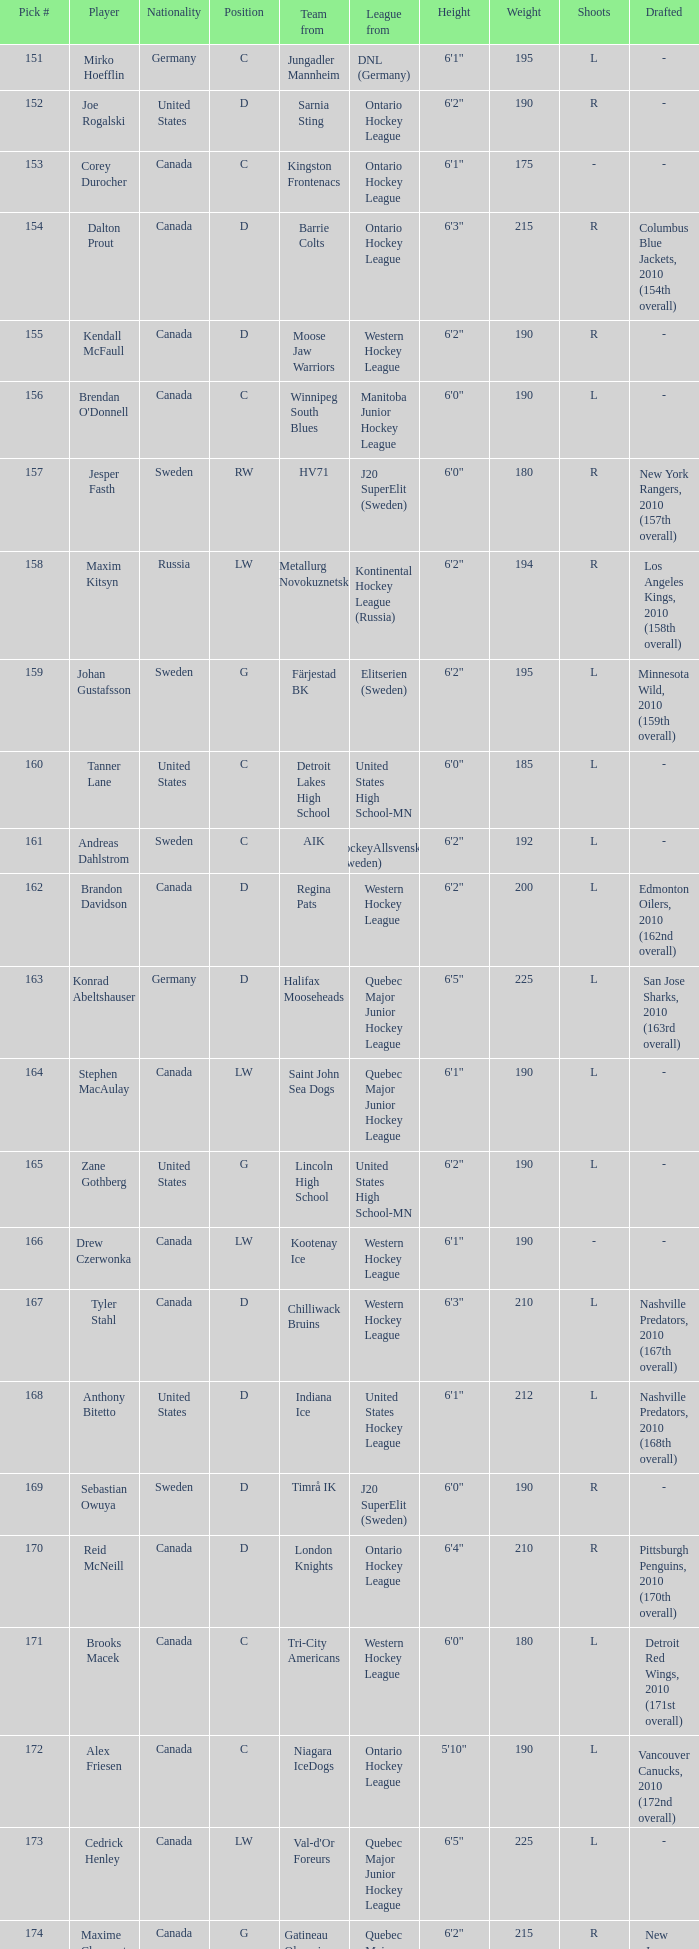Parse the full table. {'header': ['Pick #', 'Player', 'Nationality', 'Position', 'Team from', 'League from', 'Height', 'Weight', 'Shoots', 'Drafted'], 'rows': [['151', 'Mirko Hoefflin', 'Germany', 'C', 'Jungadler Mannheim', 'DNL (Germany)', '6\'1"', '195', 'L', '-'], ['152', 'Joe Rogalski', 'United States', 'D', 'Sarnia Sting', 'Ontario Hockey League', '6\'2"', '190', 'R', '-'], ['153', 'Corey Durocher', 'Canada', 'C', 'Kingston Frontenacs', 'Ontario Hockey League', '6\'1"', '175', '-', '-'], ['154', 'Dalton Prout', 'Canada', 'D', 'Barrie Colts', 'Ontario Hockey League', '6\'3"', '215', 'R', 'Columbus Blue Jackets, 2010 (154th overall)'], ['155', 'Kendall McFaull', 'Canada', 'D', 'Moose Jaw Warriors', 'Western Hockey League', '6\'2"', '190', 'R', '-'], ['156', "Brendan O'Donnell", 'Canada', 'C', 'Winnipeg South Blues', 'Manitoba Junior Hockey League', '6\'0"', '190', 'L', '-'], ['157', 'Jesper Fasth', 'Sweden', 'RW', 'HV71', 'J20 SuperElit (Sweden)', '6\'0"', '180', 'R', 'New York Rangers, 2010 (157th overall)'], ['158', 'Maxim Kitsyn', 'Russia', 'LW', 'Metallurg Novokuznetsk', 'Kontinental Hockey League (Russia)', '6\'2"', '194', 'R', 'Los Angeles Kings, 2010 (158th overall)'], ['159', 'Johan Gustafsson', 'Sweden', 'G', 'Färjestad BK', 'Elitserien (Sweden)', '6\'2"', '195', 'L', 'Minnesota Wild, 2010 (159th overall)'], ['160', 'Tanner Lane', 'United States', 'C', 'Detroit Lakes High School', 'United States High School-MN', '6\'0"', '185', 'L', '-'], ['161', 'Andreas Dahlstrom', 'Sweden', 'C', 'AIK', 'HockeyAllsvenskan (Sweden)', '6\'2"', '192', 'L', '-'], ['162', 'Brandon Davidson', 'Canada', 'D', 'Regina Pats', 'Western Hockey League', '6\'2"', '200', 'L', 'Edmonton Oilers, 2010 (162nd overall)'], ['163', 'Konrad Abeltshauser', 'Germany', 'D', 'Halifax Mooseheads', 'Quebec Major Junior Hockey League', '6\'5"', '225', 'L', 'San Jose Sharks, 2010 (163rd overall)'], ['164', 'Stephen MacAulay', 'Canada', 'LW', 'Saint John Sea Dogs', 'Quebec Major Junior Hockey League', '6\'1"', '190', 'L', '-'], ['165', 'Zane Gothberg', 'United States', 'G', 'Lincoln High School', 'United States High School-MN', '6\'2"', '190', 'L', '-'], ['166', 'Drew Czerwonka', 'Canada', 'LW', 'Kootenay Ice', 'Western Hockey League', '6\'1"', '190', '-', '-'], ['167', 'Tyler Stahl', 'Canada', 'D', 'Chilliwack Bruins', 'Western Hockey League', '6\'3"', '210', 'L', 'Nashville Predators, 2010 (167th overall)'], ['168', 'Anthony Bitetto', 'United States', 'D', 'Indiana Ice', 'United States Hockey League', '6\'1"', '212', 'L', 'Nashville Predators, 2010 (168th overall)'], ['169', 'Sebastian Owuya', 'Sweden', 'D', 'Timrå IK', 'J20 SuperElit (Sweden)', '6\'0"', '190', 'R', '-'], ['170', 'Reid McNeill', 'Canada', 'D', 'London Knights', 'Ontario Hockey League', '6\'4"', '210', 'R', 'Pittsburgh Penguins, 2010 (170th overall)'], ['171', 'Brooks Macek', 'Canada', 'C', 'Tri-City Americans', 'Western Hockey League', '6\'0"', '180', 'L', 'Detroit Red Wings, 2010 (171st overall)'], ['172', 'Alex Friesen', 'Canada', 'C', 'Niagara IceDogs', 'Ontario Hockey League', '5\'10"', '190', 'L', 'Vancouver Canucks, 2010 (172nd overall)'], ['173', 'Cedrick Henley', 'Canada', 'LW', "Val-d'Or Foreurs", 'Quebec Major Junior Hockey League', '6\'5"', '225', 'L', '-'], ['174', 'Maxime Clermont', 'Canada', 'G', 'Gatineau Olympiques', 'Quebec Major Junior Hockey League', '6\'2"', '215', 'R', 'New Jersey Devils, 2010 (174th overall)'], ['175', 'Jonathan Iilahti', 'Finland', 'G', 'Espoo Blues', 'SM-liiga Jr. (Finland)', '5\'11"', '165', 'L', '-'], ['176', 'Samuel Carrier', 'Canada', 'RW', 'Lewiston Maineiacs', 'Quebec Major Junior Hockey League', '6\'2"', '198', 'R', '-'], ['177', 'Kevin Lind', 'United States', 'D', 'Chicago Steel', 'United States Hockey League', '6\'2"', '189', 'L', 'Anaheim Ducks, 2010 (177th overall)'], ['178', 'Mark Stone', 'Canada', 'RW', 'Brandon Wheat Kings', 'Western Hockey League', '6\'4"', '219', 'R', 'Ottawa Senators, 2010 (178th overall)'], ['179', 'Nicholas Luukko', 'United States', 'D', 'The Gunnery', 'United States High School-CT', '6\'2"', '200', 'R', 'Philadelphia Flyers, 2010 (179th overall)'], ['180', 'Nick Mattson', 'United States', 'D', 'Indiana Ice', 'United States Hockey League', '6\'1"', '173', 'L', 'Chicago Blackhawks, 2010 (180th overall)']]} What is the average pick # from the Quebec Major Junior Hockey League player Samuel Carrier? 176.0. 